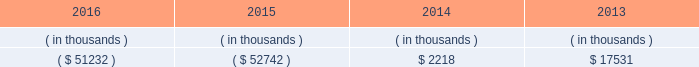Entergy arkansas , inc .
And subsidiaries management 2019s financial discussion and analysis stock restrict the amount of retained earnings available for the payment of cash dividends or other distributions on its common and preferred stock .
Sources of capital entergy arkansas 2019s sources to meet its capital requirements include : 2022 internally generated funds ; 2022 cash on hand ; 2022 debt or preferred stock issuances ; and 2022 bank financing under new or existing facilities .
Entergy arkansas may refinance , redeem , or otherwise retire debt and preferred stock prior to maturity , to the extent market conditions and interest and dividend rates are favorable .
All debt and common and preferred stock issuances by entergy arkansas require prior regulatory approval .
Preferred stock and debt issuances are also subject to issuance tests set forth in entergy arkansas 2019s corporate charters , bond indentures , and other agreements .
Entergy arkansas has sufficient capacity under these tests to meet its foreseeable capital needs .
Entergy arkansas 2019s receivables from or ( payables to ) the money pool were as follows as of december 31 for each of the following years. .
See note 4 to the financial statements for a description of the money pool .
Entergy arkansas has a credit facility in the amount of $ 150 million scheduled to expire in august 2021 .
Entergy arkansas also has a $ 20 million credit facility scheduled to expire in april 2017 .
The $ 150 million credit facility allows entergy arkansas to issue letters of credit against 50% ( 50 % ) of the borrowing capacity of the facility .
As of december 31 , 2016 , there were no cash borrowings and no letters of credit outstanding under the credit facilities .
In addition , entergy arkansas is a party to an uncommitted letter of credit facility as a means to post collateral to support its obligations under miso .
As of december 31 , 2016 , a $ 1 million letter of credit was outstanding under entergy arkansas 2019s uncommitted letter of credit facility .
See note 4 to the financial statements for additional discussion of the credit facilities .
The entergy arkansas nuclear fuel company variable interest entity has a credit facility in the amount of $ 80 million scheduled to expire in may 2019 .
As of december 31 , 2016 , no letters of credit were outstanding under the credit facility to support commercial paper issued by the entergy arkansas nuclear fuel company variable interest entity .
See note 4 to the financial statements for additional discussion of the nuclear fuel company variable interest entity credit facility .
Entergy arkansas obtained authorizations from the ferc through october 2017 for short-term borrowings not to exceed an aggregate amount of $ 250 million at any time outstanding and long-term borrowings by its nuclear fuel company variable interest entity .
See note 4 to the financial statements for further discussion of entergy arkansas 2019s short-term borrowing limits .
The long-term securities issuances of entergy arkansas are limited to amounts authorized by the apsc and the tennessee regulatory authority ; the current authorizations extend through december 2018. .
What amount of credit facilities are expiring from 2017 through 2021 , in millions?\\n? 
Computations: (150 + 20)
Answer: 170.0. 